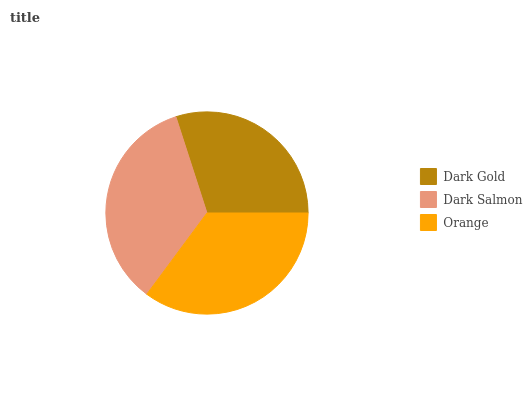Is Dark Gold the minimum?
Answer yes or no. Yes. Is Orange the maximum?
Answer yes or no. Yes. Is Dark Salmon the minimum?
Answer yes or no. No. Is Dark Salmon the maximum?
Answer yes or no. No. Is Dark Salmon greater than Dark Gold?
Answer yes or no. Yes. Is Dark Gold less than Dark Salmon?
Answer yes or no. Yes. Is Dark Gold greater than Dark Salmon?
Answer yes or no. No. Is Dark Salmon less than Dark Gold?
Answer yes or no. No. Is Dark Salmon the high median?
Answer yes or no. Yes. Is Dark Salmon the low median?
Answer yes or no. Yes. Is Orange the high median?
Answer yes or no. No. Is Orange the low median?
Answer yes or no. No. 